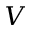Convert formula to latex. <formula><loc_0><loc_0><loc_500><loc_500>V</formula> 